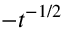Convert formula to latex. <formula><loc_0><loc_0><loc_500><loc_500>- t ^ { - 1 / 2 }</formula> 